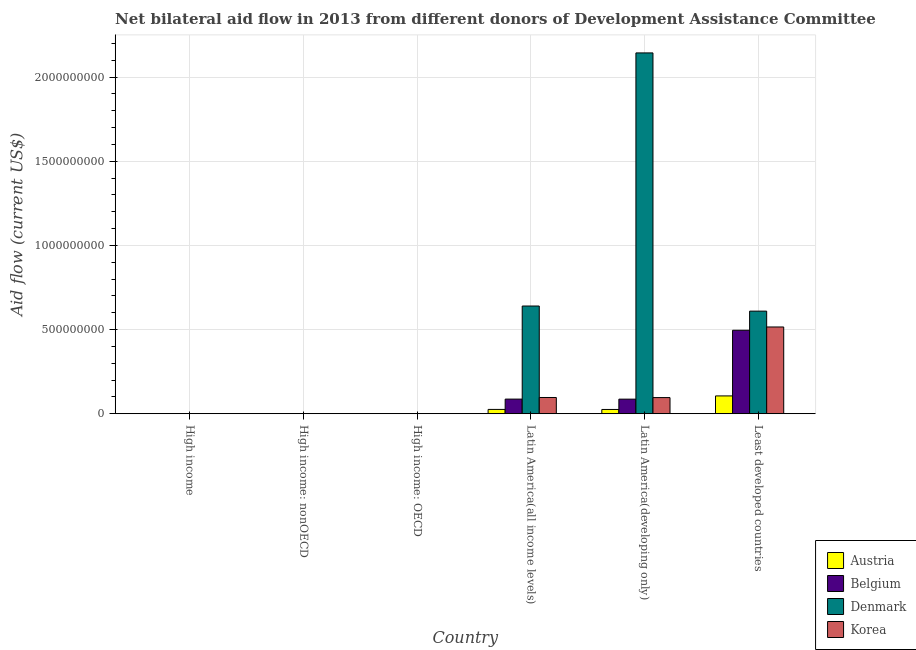How many different coloured bars are there?
Provide a short and direct response. 4. How many groups of bars are there?
Give a very brief answer. 6. Are the number of bars per tick equal to the number of legend labels?
Provide a succinct answer. No. Are the number of bars on each tick of the X-axis equal?
Your answer should be very brief. No. How many bars are there on the 2nd tick from the right?
Keep it short and to the point. 4. What is the label of the 2nd group of bars from the left?
Offer a terse response. High income: nonOECD. In how many cases, is the number of bars for a given country not equal to the number of legend labels?
Provide a succinct answer. 2. Across all countries, what is the maximum amount of aid given by denmark?
Offer a very short reply. 2.14e+09. In which country was the amount of aid given by austria maximum?
Ensure brevity in your answer.  Least developed countries. What is the total amount of aid given by austria in the graph?
Provide a succinct answer. 1.58e+08. What is the difference between the amount of aid given by belgium in High income: nonOECD and that in Latin America(developing only)?
Provide a succinct answer. -8.66e+07. What is the difference between the amount of aid given by austria in High income and the amount of aid given by korea in Least developed countries?
Ensure brevity in your answer.  -5.15e+08. What is the average amount of aid given by denmark per country?
Offer a terse response. 5.65e+08. What is the difference between the amount of aid given by korea and amount of aid given by belgium in High income: nonOECD?
Ensure brevity in your answer.  3.10e+05. What is the ratio of the amount of aid given by belgium in High income: OECD to that in High income: nonOECD?
Your answer should be very brief. 4.4. Is the amount of aid given by austria in Latin America(developing only) less than that in Least developed countries?
Offer a terse response. Yes. What is the difference between the highest and the second highest amount of aid given by belgium?
Ensure brevity in your answer.  4.09e+08. What is the difference between the highest and the lowest amount of aid given by austria?
Your answer should be compact. 1.06e+08. In how many countries, is the amount of aid given by austria greater than the average amount of aid given by austria taken over all countries?
Offer a terse response. 1. Is it the case that in every country, the sum of the amount of aid given by korea and amount of aid given by denmark is greater than the sum of amount of aid given by austria and amount of aid given by belgium?
Offer a very short reply. No. How many countries are there in the graph?
Give a very brief answer. 6. Does the graph contain any zero values?
Offer a terse response. Yes. Does the graph contain grids?
Offer a very short reply. Yes. What is the title of the graph?
Provide a short and direct response. Net bilateral aid flow in 2013 from different donors of Development Assistance Committee. Does "Management rating" appear as one of the legend labels in the graph?
Offer a very short reply. No. What is the label or title of the Y-axis?
Ensure brevity in your answer.  Aid flow (current US$). What is the Aid flow (current US$) of Korea in High income?
Give a very brief answer. 6.60e+05. What is the Aid flow (current US$) of Austria in High income: nonOECD?
Give a very brief answer. 2.00e+04. What is the Aid flow (current US$) of Belgium in High income: nonOECD?
Make the answer very short. 5.00e+04. What is the Aid flow (current US$) in Denmark in High income: nonOECD?
Your answer should be very brief. 0. What is the Aid flow (current US$) in Austria in High income: OECD?
Give a very brief answer. 3.00e+05. What is the Aid flow (current US$) in Belgium in High income: OECD?
Give a very brief answer. 2.20e+05. What is the Aid flow (current US$) in Korea in High income: OECD?
Your response must be concise. 3.00e+05. What is the Aid flow (current US$) of Austria in Latin America(all income levels)?
Provide a short and direct response. 2.57e+07. What is the Aid flow (current US$) in Belgium in Latin America(all income levels)?
Your response must be concise. 8.70e+07. What is the Aid flow (current US$) in Denmark in Latin America(all income levels)?
Give a very brief answer. 6.40e+08. What is the Aid flow (current US$) in Korea in Latin America(all income levels)?
Offer a terse response. 9.65e+07. What is the Aid flow (current US$) of Austria in Latin America(developing only)?
Your answer should be compact. 2.54e+07. What is the Aid flow (current US$) in Belgium in Latin America(developing only)?
Your answer should be compact. 8.67e+07. What is the Aid flow (current US$) in Denmark in Latin America(developing only)?
Ensure brevity in your answer.  2.14e+09. What is the Aid flow (current US$) of Korea in Latin America(developing only)?
Provide a succinct answer. 9.60e+07. What is the Aid flow (current US$) of Austria in Least developed countries?
Offer a terse response. 1.06e+08. What is the Aid flow (current US$) in Belgium in Least developed countries?
Provide a succinct answer. 4.96e+08. What is the Aid flow (current US$) in Denmark in Least developed countries?
Keep it short and to the point. 6.09e+08. What is the Aid flow (current US$) in Korea in Least developed countries?
Keep it short and to the point. 5.15e+08. Across all countries, what is the maximum Aid flow (current US$) in Austria?
Offer a very short reply. 1.06e+08. Across all countries, what is the maximum Aid flow (current US$) in Belgium?
Ensure brevity in your answer.  4.96e+08. Across all countries, what is the maximum Aid flow (current US$) of Denmark?
Give a very brief answer. 2.14e+09. Across all countries, what is the maximum Aid flow (current US$) in Korea?
Your answer should be compact. 5.15e+08. Across all countries, what is the minimum Aid flow (current US$) in Austria?
Your answer should be very brief. 2.00e+04. Across all countries, what is the minimum Aid flow (current US$) in Denmark?
Your answer should be compact. 0. Across all countries, what is the minimum Aid flow (current US$) in Korea?
Offer a very short reply. 3.00e+05. What is the total Aid flow (current US$) of Austria in the graph?
Keep it short and to the point. 1.58e+08. What is the total Aid flow (current US$) of Belgium in the graph?
Offer a very short reply. 6.70e+08. What is the total Aid flow (current US$) of Denmark in the graph?
Ensure brevity in your answer.  3.39e+09. What is the total Aid flow (current US$) of Korea in the graph?
Provide a succinct answer. 7.09e+08. What is the difference between the Aid flow (current US$) in Austria in High income and that in High income: nonOECD?
Ensure brevity in your answer.  3.00e+05. What is the difference between the Aid flow (current US$) of Belgium in High income and that in High income: OECD?
Your answer should be very brief. 5.00e+04. What is the difference between the Aid flow (current US$) in Austria in High income and that in Latin America(all income levels)?
Keep it short and to the point. -2.54e+07. What is the difference between the Aid flow (current US$) in Belgium in High income and that in Latin America(all income levels)?
Make the answer very short. -8.67e+07. What is the difference between the Aid flow (current US$) in Denmark in High income and that in Latin America(all income levels)?
Provide a short and direct response. -6.39e+08. What is the difference between the Aid flow (current US$) in Korea in High income and that in Latin America(all income levels)?
Provide a succinct answer. -9.58e+07. What is the difference between the Aid flow (current US$) of Austria in High income and that in Latin America(developing only)?
Keep it short and to the point. -2.51e+07. What is the difference between the Aid flow (current US$) in Belgium in High income and that in Latin America(developing only)?
Provide a short and direct response. -8.64e+07. What is the difference between the Aid flow (current US$) of Denmark in High income and that in Latin America(developing only)?
Your response must be concise. -2.14e+09. What is the difference between the Aid flow (current US$) in Korea in High income and that in Latin America(developing only)?
Make the answer very short. -9.53e+07. What is the difference between the Aid flow (current US$) of Austria in High income and that in Least developed countries?
Provide a short and direct response. -1.06e+08. What is the difference between the Aid flow (current US$) in Belgium in High income and that in Least developed countries?
Ensure brevity in your answer.  -4.96e+08. What is the difference between the Aid flow (current US$) in Denmark in High income and that in Least developed countries?
Make the answer very short. -6.09e+08. What is the difference between the Aid flow (current US$) of Korea in High income and that in Least developed countries?
Ensure brevity in your answer.  -5.15e+08. What is the difference between the Aid flow (current US$) of Austria in High income: nonOECD and that in High income: OECD?
Give a very brief answer. -2.80e+05. What is the difference between the Aid flow (current US$) of Belgium in High income: nonOECD and that in High income: OECD?
Offer a very short reply. -1.70e+05. What is the difference between the Aid flow (current US$) in Austria in High income: nonOECD and that in Latin America(all income levels)?
Provide a succinct answer. -2.57e+07. What is the difference between the Aid flow (current US$) of Belgium in High income: nonOECD and that in Latin America(all income levels)?
Ensure brevity in your answer.  -8.69e+07. What is the difference between the Aid flow (current US$) in Korea in High income: nonOECD and that in Latin America(all income levels)?
Provide a short and direct response. -9.61e+07. What is the difference between the Aid flow (current US$) in Austria in High income: nonOECD and that in Latin America(developing only)?
Your response must be concise. -2.54e+07. What is the difference between the Aid flow (current US$) of Belgium in High income: nonOECD and that in Latin America(developing only)?
Provide a succinct answer. -8.66e+07. What is the difference between the Aid flow (current US$) of Korea in High income: nonOECD and that in Latin America(developing only)?
Your answer should be very brief. -9.56e+07. What is the difference between the Aid flow (current US$) of Austria in High income: nonOECD and that in Least developed countries?
Your response must be concise. -1.06e+08. What is the difference between the Aid flow (current US$) of Belgium in High income: nonOECD and that in Least developed countries?
Offer a very short reply. -4.96e+08. What is the difference between the Aid flow (current US$) in Korea in High income: nonOECD and that in Least developed countries?
Your answer should be compact. -5.15e+08. What is the difference between the Aid flow (current US$) in Austria in High income: OECD and that in Latin America(all income levels)?
Give a very brief answer. -2.54e+07. What is the difference between the Aid flow (current US$) of Belgium in High income: OECD and that in Latin America(all income levels)?
Your answer should be very brief. -8.67e+07. What is the difference between the Aid flow (current US$) of Korea in High income: OECD and that in Latin America(all income levels)?
Your response must be concise. -9.62e+07. What is the difference between the Aid flow (current US$) in Austria in High income: OECD and that in Latin America(developing only)?
Your response must be concise. -2.51e+07. What is the difference between the Aid flow (current US$) of Belgium in High income: OECD and that in Latin America(developing only)?
Your answer should be very brief. -8.65e+07. What is the difference between the Aid flow (current US$) in Korea in High income: OECD and that in Latin America(developing only)?
Provide a short and direct response. -9.57e+07. What is the difference between the Aid flow (current US$) of Austria in High income: OECD and that in Least developed countries?
Your answer should be compact. -1.06e+08. What is the difference between the Aid flow (current US$) in Belgium in High income: OECD and that in Least developed countries?
Offer a terse response. -4.96e+08. What is the difference between the Aid flow (current US$) in Korea in High income: OECD and that in Least developed countries?
Ensure brevity in your answer.  -5.15e+08. What is the difference between the Aid flow (current US$) of Austria in Latin America(all income levels) and that in Latin America(developing only)?
Make the answer very short. 3.00e+05. What is the difference between the Aid flow (current US$) of Denmark in Latin America(all income levels) and that in Latin America(developing only)?
Give a very brief answer. -1.50e+09. What is the difference between the Aid flow (current US$) of Korea in Latin America(all income levels) and that in Latin America(developing only)?
Provide a succinct answer. 5.20e+05. What is the difference between the Aid flow (current US$) in Austria in Latin America(all income levels) and that in Least developed countries?
Your answer should be very brief. -8.02e+07. What is the difference between the Aid flow (current US$) of Belgium in Latin America(all income levels) and that in Least developed countries?
Give a very brief answer. -4.09e+08. What is the difference between the Aid flow (current US$) of Denmark in Latin America(all income levels) and that in Least developed countries?
Your answer should be very brief. 3.03e+07. What is the difference between the Aid flow (current US$) of Korea in Latin America(all income levels) and that in Least developed countries?
Keep it short and to the point. -4.19e+08. What is the difference between the Aid flow (current US$) in Austria in Latin America(developing only) and that in Least developed countries?
Offer a very short reply. -8.05e+07. What is the difference between the Aid flow (current US$) of Belgium in Latin America(developing only) and that in Least developed countries?
Ensure brevity in your answer.  -4.09e+08. What is the difference between the Aid flow (current US$) of Denmark in Latin America(developing only) and that in Least developed countries?
Provide a succinct answer. 1.53e+09. What is the difference between the Aid flow (current US$) in Korea in Latin America(developing only) and that in Least developed countries?
Your answer should be very brief. -4.19e+08. What is the difference between the Aid flow (current US$) of Austria in High income and the Aid flow (current US$) of Korea in High income: nonOECD?
Your answer should be very brief. -4.00e+04. What is the difference between the Aid flow (current US$) of Belgium in High income and the Aid flow (current US$) of Korea in High income: nonOECD?
Give a very brief answer. -9.00e+04. What is the difference between the Aid flow (current US$) in Denmark in High income and the Aid flow (current US$) in Korea in High income: nonOECD?
Offer a very short reply. 0. What is the difference between the Aid flow (current US$) of Austria in High income and the Aid flow (current US$) of Belgium in Latin America(all income levels)?
Your answer should be very brief. -8.66e+07. What is the difference between the Aid flow (current US$) in Austria in High income and the Aid flow (current US$) in Denmark in Latin America(all income levels)?
Make the answer very short. -6.39e+08. What is the difference between the Aid flow (current US$) of Austria in High income and the Aid flow (current US$) of Korea in Latin America(all income levels)?
Provide a succinct answer. -9.62e+07. What is the difference between the Aid flow (current US$) in Belgium in High income and the Aid flow (current US$) in Denmark in Latin America(all income levels)?
Keep it short and to the point. -6.39e+08. What is the difference between the Aid flow (current US$) in Belgium in High income and the Aid flow (current US$) in Korea in Latin America(all income levels)?
Your answer should be very brief. -9.62e+07. What is the difference between the Aid flow (current US$) of Denmark in High income and the Aid flow (current US$) of Korea in Latin America(all income levels)?
Keep it short and to the point. -9.61e+07. What is the difference between the Aid flow (current US$) in Austria in High income and the Aid flow (current US$) in Belgium in Latin America(developing only)?
Your response must be concise. -8.64e+07. What is the difference between the Aid flow (current US$) of Austria in High income and the Aid flow (current US$) of Denmark in Latin America(developing only)?
Keep it short and to the point. -2.14e+09. What is the difference between the Aid flow (current US$) of Austria in High income and the Aid flow (current US$) of Korea in Latin America(developing only)?
Ensure brevity in your answer.  -9.56e+07. What is the difference between the Aid flow (current US$) in Belgium in High income and the Aid flow (current US$) in Denmark in Latin America(developing only)?
Your answer should be compact. -2.14e+09. What is the difference between the Aid flow (current US$) of Belgium in High income and the Aid flow (current US$) of Korea in Latin America(developing only)?
Your response must be concise. -9.57e+07. What is the difference between the Aid flow (current US$) in Denmark in High income and the Aid flow (current US$) in Korea in Latin America(developing only)?
Your answer should be very brief. -9.56e+07. What is the difference between the Aid flow (current US$) of Austria in High income and the Aid flow (current US$) of Belgium in Least developed countries?
Provide a succinct answer. -4.96e+08. What is the difference between the Aid flow (current US$) in Austria in High income and the Aid flow (current US$) in Denmark in Least developed countries?
Your answer should be very brief. -6.09e+08. What is the difference between the Aid flow (current US$) of Austria in High income and the Aid flow (current US$) of Korea in Least developed countries?
Keep it short and to the point. -5.15e+08. What is the difference between the Aid flow (current US$) of Belgium in High income and the Aid flow (current US$) of Denmark in Least developed countries?
Ensure brevity in your answer.  -6.09e+08. What is the difference between the Aid flow (current US$) in Belgium in High income and the Aid flow (current US$) in Korea in Least developed countries?
Keep it short and to the point. -5.15e+08. What is the difference between the Aid flow (current US$) in Denmark in High income and the Aid flow (current US$) in Korea in Least developed countries?
Make the answer very short. -5.15e+08. What is the difference between the Aid flow (current US$) of Austria in High income: nonOECD and the Aid flow (current US$) of Belgium in High income: OECD?
Ensure brevity in your answer.  -2.00e+05. What is the difference between the Aid flow (current US$) of Austria in High income: nonOECD and the Aid flow (current US$) of Korea in High income: OECD?
Offer a terse response. -2.80e+05. What is the difference between the Aid flow (current US$) in Austria in High income: nonOECD and the Aid flow (current US$) in Belgium in Latin America(all income levels)?
Your response must be concise. -8.69e+07. What is the difference between the Aid flow (current US$) in Austria in High income: nonOECD and the Aid flow (current US$) in Denmark in Latin America(all income levels)?
Provide a succinct answer. -6.40e+08. What is the difference between the Aid flow (current US$) in Austria in High income: nonOECD and the Aid flow (current US$) in Korea in Latin America(all income levels)?
Your answer should be compact. -9.65e+07. What is the difference between the Aid flow (current US$) of Belgium in High income: nonOECD and the Aid flow (current US$) of Denmark in Latin America(all income levels)?
Your answer should be very brief. -6.40e+08. What is the difference between the Aid flow (current US$) in Belgium in High income: nonOECD and the Aid flow (current US$) in Korea in Latin America(all income levels)?
Provide a succinct answer. -9.64e+07. What is the difference between the Aid flow (current US$) in Austria in High income: nonOECD and the Aid flow (current US$) in Belgium in Latin America(developing only)?
Ensure brevity in your answer.  -8.67e+07. What is the difference between the Aid flow (current US$) in Austria in High income: nonOECD and the Aid flow (current US$) in Denmark in Latin America(developing only)?
Provide a succinct answer. -2.14e+09. What is the difference between the Aid flow (current US$) in Austria in High income: nonOECD and the Aid flow (current US$) in Korea in Latin America(developing only)?
Offer a terse response. -9.59e+07. What is the difference between the Aid flow (current US$) of Belgium in High income: nonOECD and the Aid flow (current US$) of Denmark in Latin America(developing only)?
Ensure brevity in your answer.  -2.14e+09. What is the difference between the Aid flow (current US$) of Belgium in High income: nonOECD and the Aid flow (current US$) of Korea in Latin America(developing only)?
Ensure brevity in your answer.  -9.59e+07. What is the difference between the Aid flow (current US$) in Austria in High income: nonOECD and the Aid flow (current US$) in Belgium in Least developed countries?
Your answer should be very brief. -4.96e+08. What is the difference between the Aid flow (current US$) in Austria in High income: nonOECD and the Aid flow (current US$) in Denmark in Least developed countries?
Your response must be concise. -6.09e+08. What is the difference between the Aid flow (current US$) in Austria in High income: nonOECD and the Aid flow (current US$) in Korea in Least developed countries?
Your answer should be very brief. -5.15e+08. What is the difference between the Aid flow (current US$) in Belgium in High income: nonOECD and the Aid flow (current US$) in Denmark in Least developed countries?
Keep it short and to the point. -6.09e+08. What is the difference between the Aid flow (current US$) in Belgium in High income: nonOECD and the Aid flow (current US$) in Korea in Least developed countries?
Your answer should be very brief. -5.15e+08. What is the difference between the Aid flow (current US$) in Austria in High income: OECD and the Aid flow (current US$) in Belgium in Latin America(all income levels)?
Offer a terse response. -8.67e+07. What is the difference between the Aid flow (current US$) in Austria in High income: OECD and the Aid flow (current US$) in Denmark in Latin America(all income levels)?
Provide a succinct answer. -6.39e+08. What is the difference between the Aid flow (current US$) in Austria in High income: OECD and the Aid flow (current US$) in Korea in Latin America(all income levels)?
Keep it short and to the point. -9.62e+07. What is the difference between the Aid flow (current US$) in Belgium in High income: OECD and the Aid flow (current US$) in Denmark in Latin America(all income levels)?
Offer a terse response. -6.40e+08. What is the difference between the Aid flow (current US$) of Belgium in High income: OECD and the Aid flow (current US$) of Korea in Latin America(all income levels)?
Your response must be concise. -9.63e+07. What is the difference between the Aid flow (current US$) of Austria in High income: OECD and the Aid flow (current US$) of Belgium in Latin America(developing only)?
Ensure brevity in your answer.  -8.64e+07. What is the difference between the Aid flow (current US$) of Austria in High income: OECD and the Aid flow (current US$) of Denmark in Latin America(developing only)?
Your answer should be compact. -2.14e+09. What is the difference between the Aid flow (current US$) of Austria in High income: OECD and the Aid flow (current US$) of Korea in Latin America(developing only)?
Your response must be concise. -9.57e+07. What is the difference between the Aid flow (current US$) in Belgium in High income: OECD and the Aid flow (current US$) in Denmark in Latin America(developing only)?
Give a very brief answer. -2.14e+09. What is the difference between the Aid flow (current US$) of Belgium in High income: OECD and the Aid flow (current US$) of Korea in Latin America(developing only)?
Your answer should be compact. -9.57e+07. What is the difference between the Aid flow (current US$) of Austria in High income: OECD and the Aid flow (current US$) of Belgium in Least developed countries?
Keep it short and to the point. -4.96e+08. What is the difference between the Aid flow (current US$) in Austria in High income: OECD and the Aid flow (current US$) in Denmark in Least developed countries?
Provide a succinct answer. -6.09e+08. What is the difference between the Aid flow (current US$) in Austria in High income: OECD and the Aid flow (current US$) in Korea in Least developed countries?
Keep it short and to the point. -5.15e+08. What is the difference between the Aid flow (current US$) of Belgium in High income: OECD and the Aid flow (current US$) of Denmark in Least developed countries?
Provide a succinct answer. -6.09e+08. What is the difference between the Aid flow (current US$) of Belgium in High income: OECD and the Aid flow (current US$) of Korea in Least developed countries?
Ensure brevity in your answer.  -5.15e+08. What is the difference between the Aid flow (current US$) in Austria in Latin America(all income levels) and the Aid flow (current US$) in Belgium in Latin America(developing only)?
Keep it short and to the point. -6.10e+07. What is the difference between the Aid flow (current US$) of Austria in Latin America(all income levels) and the Aid flow (current US$) of Denmark in Latin America(developing only)?
Make the answer very short. -2.12e+09. What is the difference between the Aid flow (current US$) of Austria in Latin America(all income levels) and the Aid flow (current US$) of Korea in Latin America(developing only)?
Offer a very short reply. -7.02e+07. What is the difference between the Aid flow (current US$) of Belgium in Latin America(all income levels) and the Aid flow (current US$) of Denmark in Latin America(developing only)?
Provide a succinct answer. -2.06e+09. What is the difference between the Aid flow (current US$) in Belgium in Latin America(all income levels) and the Aid flow (current US$) in Korea in Latin America(developing only)?
Offer a very short reply. -9.00e+06. What is the difference between the Aid flow (current US$) of Denmark in Latin America(all income levels) and the Aid flow (current US$) of Korea in Latin America(developing only)?
Provide a short and direct response. 5.44e+08. What is the difference between the Aid flow (current US$) in Austria in Latin America(all income levels) and the Aid flow (current US$) in Belgium in Least developed countries?
Give a very brief answer. -4.70e+08. What is the difference between the Aid flow (current US$) in Austria in Latin America(all income levels) and the Aid flow (current US$) in Denmark in Least developed countries?
Your answer should be compact. -5.84e+08. What is the difference between the Aid flow (current US$) in Austria in Latin America(all income levels) and the Aid flow (current US$) in Korea in Least developed countries?
Offer a very short reply. -4.90e+08. What is the difference between the Aid flow (current US$) of Belgium in Latin America(all income levels) and the Aid flow (current US$) of Denmark in Least developed countries?
Offer a terse response. -5.22e+08. What is the difference between the Aid flow (current US$) of Belgium in Latin America(all income levels) and the Aid flow (current US$) of Korea in Least developed countries?
Keep it short and to the point. -4.28e+08. What is the difference between the Aid flow (current US$) of Denmark in Latin America(all income levels) and the Aid flow (current US$) of Korea in Least developed countries?
Give a very brief answer. 1.24e+08. What is the difference between the Aid flow (current US$) in Austria in Latin America(developing only) and the Aid flow (current US$) in Belgium in Least developed countries?
Ensure brevity in your answer.  -4.70e+08. What is the difference between the Aid flow (current US$) of Austria in Latin America(developing only) and the Aid flow (current US$) of Denmark in Least developed countries?
Make the answer very short. -5.84e+08. What is the difference between the Aid flow (current US$) in Austria in Latin America(developing only) and the Aid flow (current US$) in Korea in Least developed countries?
Give a very brief answer. -4.90e+08. What is the difference between the Aid flow (current US$) in Belgium in Latin America(developing only) and the Aid flow (current US$) in Denmark in Least developed countries?
Your answer should be very brief. -5.23e+08. What is the difference between the Aid flow (current US$) of Belgium in Latin America(developing only) and the Aid flow (current US$) of Korea in Least developed countries?
Provide a succinct answer. -4.29e+08. What is the difference between the Aid flow (current US$) in Denmark in Latin America(developing only) and the Aid flow (current US$) in Korea in Least developed countries?
Your answer should be compact. 1.63e+09. What is the average Aid flow (current US$) of Austria per country?
Your answer should be very brief. 2.63e+07. What is the average Aid flow (current US$) of Belgium per country?
Your response must be concise. 1.12e+08. What is the average Aid flow (current US$) in Denmark per country?
Provide a short and direct response. 5.65e+08. What is the average Aid flow (current US$) of Korea per country?
Ensure brevity in your answer.  1.18e+08. What is the difference between the Aid flow (current US$) of Austria and Aid flow (current US$) of Belgium in High income?
Give a very brief answer. 5.00e+04. What is the difference between the Aid flow (current US$) in Austria and Aid flow (current US$) in Denmark in High income?
Ensure brevity in your answer.  -4.00e+04. What is the difference between the Aid flow (current US$) of Belgium and Aid flow (current US$) of Denmark in High income?
Make the answer very short. -9.00e+04. What is the difference between the Aid flow (current US$) of Belgium and Aid flow (current US$) of Korea in High income?
Your answer should be very brief. -3.90e+05. What is the difference between the Aid flow (current US$) of Denmark and Aid flow (current US$) of Korea in High income?
Provide a succinct answer. -3.00e+05. What is the difference between the Aid flow (current US$) in Austria and Aid flow (current US$) in Belgium in High income: nonOECD?
Offer a very short reply. -3.00e+04. What is the difference between the Aid flow (current US$) in Belgium and Aid flow (current US$) in Korea in High income: nonOECD?
Your answer should be very brief. -3.10e+05. What is the difference between the Aid flow (current US$) in Austria and Aid flow (current US$) in Belgium in Latin America(all income levels)?
Provide a short and direct response. -6.12e+07. What is the difference between the Aid flow (current US$) in Austria and Aid flow (current US$) in Denmark in Latin America(all income levels)?
Offer a terse response. -6.14e+08. What is the difference between the Aid flow (current US$) of Austria and Aid flow (current US$) of Korea in Latin America(all income levels)?
Provide a succinct answer. -7.08e+07. What is the difference between the Aid flow (current US$) in Belgium and Aid flow (current US$) in Denmark in Latin America(all income levels)?
Keep it short and to the point. -5.53e+08. What is the difference between the Aid flow (current US$) of Belgium and Aid flow (current US$) of Korea in Latin America(all income levels)?
Keep it short and to the point. -9.52e+06. What is the difference between the Aid flow (current US$) in Denmark and Aid flow (current US$) in Korea in Latin America(all income levels)?
Keep it short and to the point. 5.43e+08. What is the difference between the Aid flow (current US$) in Austria and Aid flow (current US$) in Belgium in Latin America(developing only)?
Provide a short and direct response. -6.13e+07. What is the difference between the Aid flow (current US$) in Austria and Aid flow (current US$) in Denmark in Latin America(developing only)?
Keep it short and to the point. -2.12e+09. What is the difference between the Aid flow (current US$) in Austria and Aid flow (current US$) in Korea in Latin America(developing only)?
Make the answer very short. -7.05e+07. What is the difference between the Aid flow (current US$) of Belgium and Aid flow (current US$) of Denmark in Latin America(developing only)?
Your response must be concise. -2.06e+09. What is the difference between the Aid flow (current US$) in Belgium and Aid flow (current US$) in Korea in Latin America(developing only)?
Provide a succinct answer. -9.27e+06. What is the difference between the Aid flow (current US$) in Denmark and Aid flow (current US$) in Korea in Latin America(developing only)?
Your answer should be compact. 2.05e+09. What is the difference between the Aid flow (current US$) in Austria and Aid flow (current US$) in Belgium in Least developed countries?
Provide a succinct answer. -3.90e+08. What is the difference between the Aid flow (current US$) in Austria and Aid flow (current US$) in Denmark in Least developed countries?
Give a very brief answer. -5.03e+08. What is the difference between the Aid flow (current US$) of Austria and Aid flow (current US$) of Korea in Least developed countries?
Your answer should be compact. -4.09e+08. What is the difference between the Aid flow (current US$) of Belgium and Aid flow (current US$) of Denmark in Least developed countries?
Make the answer very short. -1.14e+08. What is the difference between the Aid flow (current US$) of Belgium and Aid flow (current US$) of Korea in Least developed countries?
Give a very brief answer. -1.95e+07. What is the difference between the Aid flow (current US$) in Denmark and Aid flow (current US$) in Korea in Least developed countries?
Keep it short and to the point. 9.41e+07. What is the ratio of the Aid flow (current US$) in Belgium in High income to that in High income: nonOECD?
Give a very brief answer. 5.4. What is the ratio of the Aid flow (current US$) of Korea in High income to that in High income: nonOECD?
Your answer should be compact. 1.83. What is the ratio of the Aid flow (current US$) of Austria in High income to that in High income: OECD?
Offer a terse response. 1.07. What is the ratio of the Aid flow (current US$) of Belgium in High income to that in High income: OECD?
Offer a very short reply. 1.23. What is the ratio of the Aid flow (current US$) of Austria in High income to that in Latin America(all income levels)?
Your response must be concise. 0.01. What is the ratio of the Aid flow (current US$) of Belgium in High income to that in Latin America(all income levels)?
Make the answer very short. 0. What is the ratio of the Aid flow (current US$) in Denmark in High income to that in Latin America(all income levels)?
Keep it short and to the point. 0. What is the ratio of the Aid flow (current US$) in Korea in High income to that in Latin America(all income levels)?
Your response must be concise. 0.01. What is the ratio of the Aid flow (current US$) in Austria in High income to that in Latin America(developing only)?
Offer a very short reply. 0.01. What is the ratio of the Aid flow (current US$) of Belgium in High income to that in Latin America(developing only)?
Provide a short and direct response. 0. What is the ratio of the Aid flow (current US$) in Korea in High income to that in Latin America(developing only)?
Your answer should be compact. 0.01. What is the ratio of the Aid flow (current US$) of Austria in High income to that in Least developed countries?
Give a very brief answer. 0. What is the ratio of the Aid flow (current US$) of Denmark in High income to that in Least developed countries?
Your response must be concise. 0. What is the ratio of the Aid flow (current US$) of Korea in High income to that in Least developed countries?
Keep it short and to the point. 0. What is the ratio of the Aid flow (current US$) of Austria in High income: nonOECD to that in High income: OECD?
Provide a succinct answer. 0.07. What is the ratio of the Aid flow (current US$) in Belgium in High income: nonOECD to that in High income: OECD?
Give a very brief answer. 0.23. What is the ratio of the Aid flow (current US$) in Austria in High income: nonOECD to that in Latin America(all income levels)?
Offer a terse response. 0. What is the ratio of the Aid flow (current US$) of Belgium in High income: nonOECD to that in Latin America(all income levels)?
Offer a very short reply. 0. What is the ratio of the Aid flow (current US$) of Korea in High income: nonOECD to that in Latin America(all income levels)?
Your answer should be very brief. 0. What is the ratio of the Aid flow (current US$) in Austria in High income: nonOECD to that in Latin America(developing only)?
Provide a succinct answer. 0. What is the ratio of the Aid flow (current US$) of Belgium in High income: nonOECD to that in Latin America(developing only)?
Make the answer very short. 0. What is the ratio of the Aid flow (current US$) in Korea in High income: nonOECD to that in Latin America(developing only)?
Ensure brevity in your answer.  0. What is the ratio of the Aid flow (current US$) in Belgium in High income: nonOECD to that in Least developed countries?
Your answer should be very brief. 0. What is the ratio of the Aid flow (current US$) of Korea in High income: nonOECD to that in Least developed countries?
Make the answer very short. 0. What is the ratio of the Aid flow (current US$) in Austria in High income: OECD to that in Latin America(all income levels)?
Provide a short and direct response. 0.01. What is the ratio of the Aid flow (current US$) in Belgium in High income: OECD to that in Latin America(all income levels)?
Offer a terse response. 0. What is the ratio of the Aid flow (current US$) of Korea in High income: OECD to that in Latin America(all income levels)?
Your answer should be very brief. 0. What is the ratio of the Aid flow (current US$) of Austria in High income: OECD to that in Latin America(developing only)?
Your answer should be compact. 0.01. What is the ratio of the Aid flow (current US$) in Belgium in High income: OECD to that in Latin America(developing only)?
Your answer should be very brief. 0. What is the ratio of the Aid flow (current US$) in Korea in High income: OECD to that in Latin America(developing only)?
Your answer should be very brief. 0. What is the ratio of the Aid flow (current US$) in Austria in High income: OECD to that in Least developed countries?
Offer a very short reply. 0. What is the ratio of the Aid flow (current US$) in Belgium in High income: OECD to that in Least developed countries?
Keep it short and to the point. 0. What is the ratio of the Aid flow (current US$) of Korea in High income: OECD to that in Least developed countries?
Ensure brevity in your answer.  0. What is the ratio of the Aid flow (current US$) of Austria in Latin America(all income levels) to that in Latin America(developing only)?
Your answer should be very brief. 1.01. What is the ratio of the Aid flow (current US$) of Belgium in Latin America(all income levels) to that in Latin America(developing only)?
Give a very brief answer. 1. What is the ratio of the Aid flow (current US$) of Denmark in Latin America(all income levels) to that in Latin America(developing only)?
Give a very brief answer. 0.3. What is the ratio of the Aid flow (current US$) of Korea in Latin America(all income levels) to that in Latin America(developing only)?
Provide a short and direct response. 1.01. What is the ratio of the Aid flow (current US$) of Austria in Latin America(all income levels) to that in Least developed countries?
Offer a very short reply. 0.24. What is the ratio of the Aid flow (current US$) of Belgium in Latin America(all income levels) to that in Least developed countries?
Give a very brief answer. 0.18. What is the ratio of the Aid flow (current US$) in Denmark in Latin America(all income levels) to that in Least developed countries?
Keep it short and to the point. 1.05. What is the ratio of the Aid flow (current US$) of Korea in Latin America(all income levels) to that in Least developed countries?
Provide a short and direct response. 0.19. What is the ratio of the Aid flow (current US$) of Austria in Latin America(developing only) to that in Least developed countries?
Offer a terse response. 0.24. What is the ratio of the Aid flow (current US$) in Belgium in Latin America(developing only) to that in Least developed countries?
Give a very brief answer. 0.17. What is the ratio of the Aid flow (current US$) of Denmark in Latin America(developing only) to that in Least developed countries?
Keep it short and to the point. 3.52. What is the ratio of the Aid flow (current US$) in Korea in Latin America(developing only) to that in Least developed countries?
Ensure brevity in your answer.  0.19. What is the difference between the highest and the second highest Aid flow (current US$) in Austria?
Give a very brief answer. 8.02e+07. What is the difference between the highest and the second highest Aid flow (current US$) in Belgium?
Keep it short and to the point. 4.09e+08. What is the difference between the highest and the second highest Aid flow (current US$) in Denmark?
Your answer should be very brief. 1.50e+09. What is the difference between the highest and the second highest Aid flow (current US$) of Korea?
Offer a terse response. 4.19e+08. What is the difference between the highest and the lowest Aid flow (current US$) of Austria?
Make the answer very short. 1.06e+08. What is the difference between the highest and the lowest Aid flow (current US$) in Belgium?
Make the answer very short. 4.96e+08. What is the difference between the highest and the lowest Aid flow (current US$) of Denmark?
Ensure brevity in your answer.  2.14e+09. What is the difference between the highest and the lowest Aid flow (current US$) in Korea?
Keep it short and to the point. 5.15e+08. 